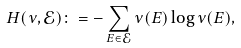Convert formula to latex. <formula><loc_0><loc_0><loc_500><loc_500>H ( \nu , \mathcal { E } ) \colon = - \sum _ { E \in \mathcal { E } } \nu ( E ) \log \nu ( E ) ,</formula> 